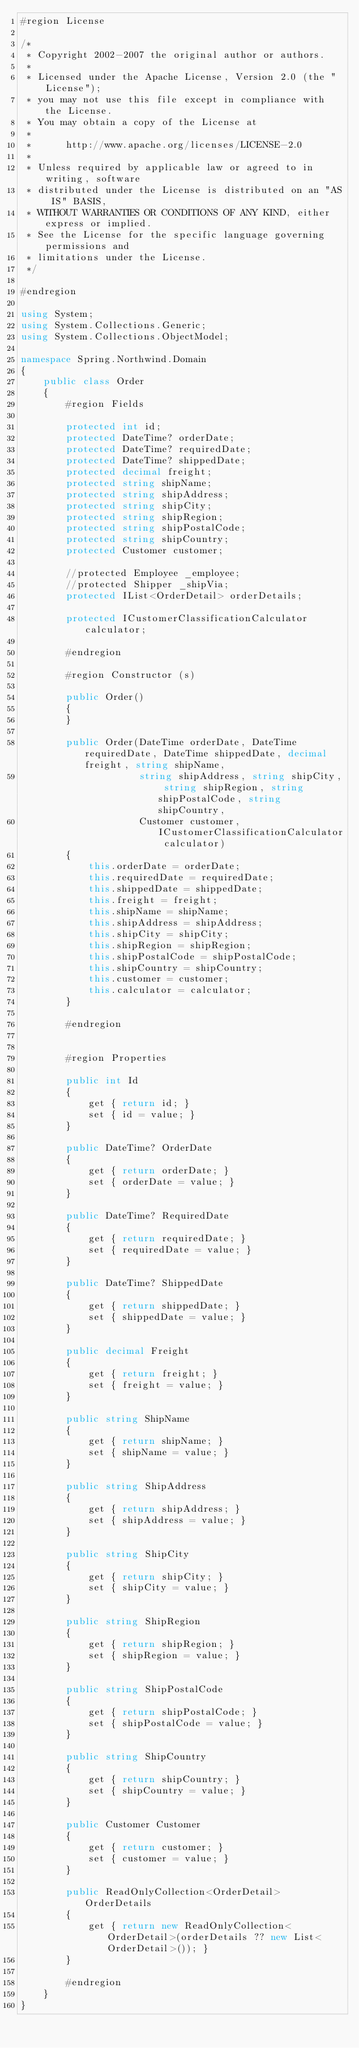<code> <loc_0><loc_0><loc_500><loc_500><_C#_>#region License

/*
 * Copyright 2002-2007 the original author or authors.
 *
 * Licensed under the Apache License, Version 2.0 (the "License");
 * you may not use this file except in compliance with the License.
 * You may obtain a copy of the License at
 *
 *      http://www.apache.org/licenses/LICENSE-2.0
 *
 * Unless required by applicable law or agreed to in writing, software
 * distributed under the License is distributed on an "AS IS" BASIS,
 * WITHOUT WARRANTIES OR CONDITIONS OF ANY KIND, either express or implied.
 * See the License for the specific language governing permissions and
 * limitations under the License.
 */

#endregion

using System;
using System.Collections.Generic;
using System.Collections.ObjectModel;

namespace Spring.Northwind.Domain
{
    public class Order
    {
        #region Fields

        protected int id;
        protected DateTime? orderDate;
        protected DateTime? requiredDate;
        protected DateTime? shippedDate;
        protected decimal freight;
        protected string shipName;
        protected string shipAddress;
        protected string shipCity;
        protected string shipRegion;
        protected string shipPostalCode;
        protected string shipCountry;
        protected Customer customer;

        //protected Employee _employee;
        //protected Shipper _shipVia;
        protected IList<OrderDetail> orderDetails;

        protected ICustomerClassificationCalculator calculator;

        #endregion

        #region Constructor (s)

        public Order()
        {
        }

        public Order(DateTime orderDate, DateTime requiredDate, DateTime shippedDate, decimal freight, string shipName,
                     string shipAddress, string shipCity, string shipRegion, string shipPostalCode, string shipCountry,
                     Customer customer, ICustomerClassificationCalculator calculator)
        {
            this.orderDate = orderDate;
            this.requiredDate = requiredDate;
            this.shippedDate = shippedDate;
            this.freight = freight;
            this.shipName = shipName;
            this.shipAddress = shipAddress;
            this.shipCity = shipCity;
            this.shipRegion = shipRegion;
            this.shipPostalCode = shipPostalCode;
            this.shipCountry = shipCountry;
            this.customer = customer;
            this.calculator = calculator;
        }

        #endregion


        #region Properties

        public int Id
        {
            get { return id; }
            set { id = value; }
        }

        public DateTime? OrderDate
        {
            get { return orderDate; }
            set { orderDate = value; }
        }

        public DateTime? RequiredDate
        {
            get { return requiredDate; }
            set { requiredDate = value; }
        }

        public DateTime? ShippedDate
        {
            get { return shippedDate; }
            set { shippedDate = value; }
        }

        public decimal Freight
        {
            get { return freight; }
            set { freight = value; }
        }

        public string ShipName
        {
            get { return shipName; }
            set { shipName = value; }
        }

        public string ShipAddress
        {
            get { return shipAddress; }
            set { shipAddress = value; }
        }

        public string ShipCity
        {
            get { return shipCity; }
            set { shipCity = value; }
        }

        public string ShipRegion
        {
            get { return shipRegion; }
            set { shipRegion = value; }
        }

        public string ShipPostalCode
        {
            get { return shipPostalCode; }
            set { shipPostalCode = value; }
        }

        public string ShipCountry
        {
            get { return shipCountry; }
            set { shipCountry = value; }
        }

        public Customer Customer
        {
            get { return customer; }
            set { customer = value; }
        }

        public ReadOnlyCollection<OrderDetail> OrderDetails
        {
            get { return new ReadOnlyCollection<OrderDetail>(orderDetails ?? new List<OrderDetail>()); }
        }

        #endregion
    }
}</code> 